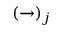<formula> <loc_0><loc_0><loc_500><loc_500>( \rightarrow ) _ { j }</formula> 